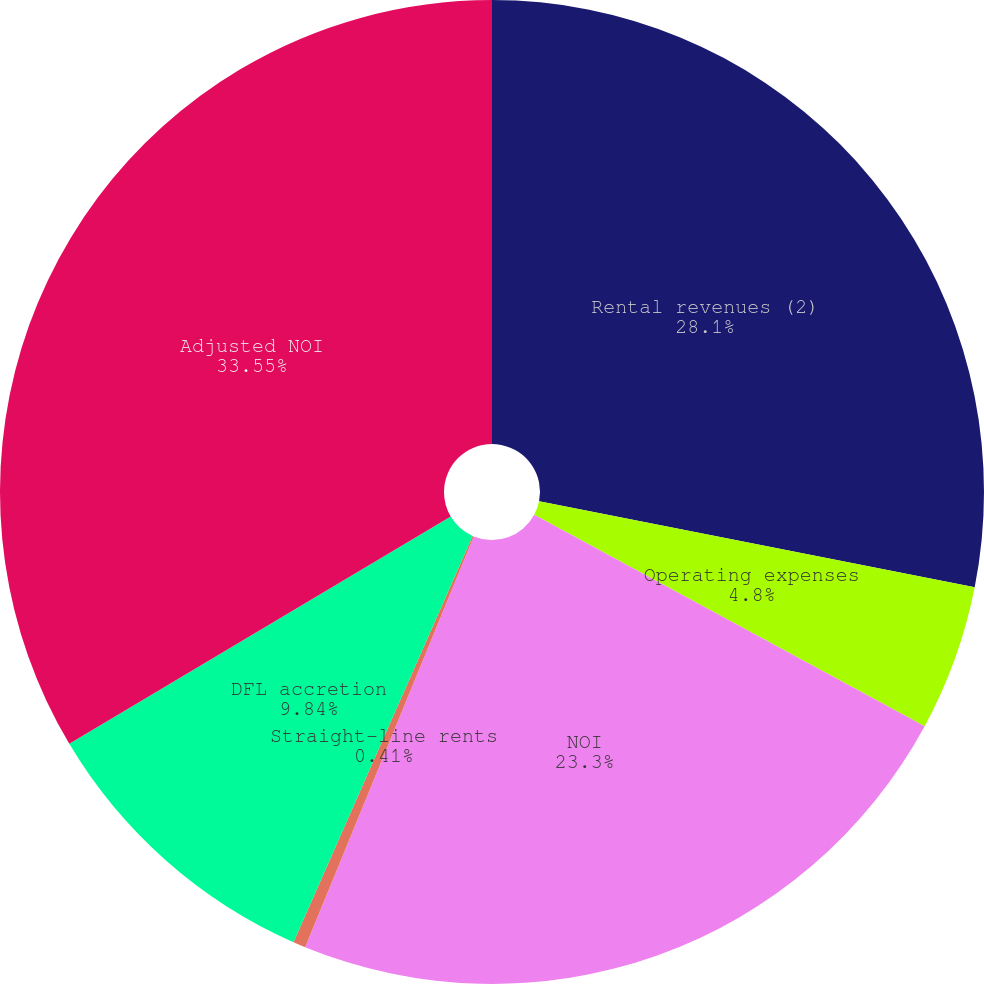<chart> <loc_0><loc_0><loc_500><loc_500><pie_chart><fcel>Rental revenues (2)<fcel>Operating expenses<fcel>NOI<fcel>Straight-line rents<fcel>DFL accretion<fcel>Adjusted NOI<nl><fcel>28.1%<fcel>4.8%<fcel>23.3%<fcel>0.41%<fcel>9.84%<fcel>33.55%<nl></chart> 